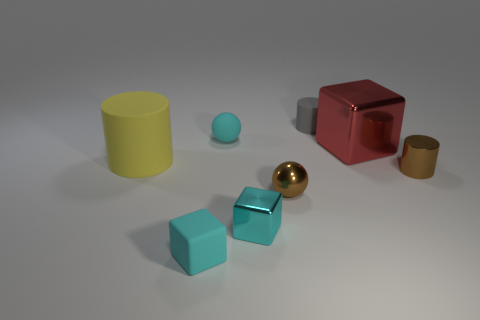There is a cylinder that is right of the big matte object and behind the brown cylinder; what is its size?
Your response must be concise. Small. There is a small cyan thing that is in front of the tiny cyan rubber sphere and right of the cyan rubber cube; what is its shape?
Provide a short and direct response. Cube. There is a small cube that is right of the cyan matte object that is in front of the yellow rubber cylinder; is there a yellow rubber cylinder that is to the right of it?
Your answer should be compact. No. What number of objects are rubber things that are in front of the gray matte thing or cubes that are in front of the large yellow cylinder?
Offer a terse response. 4. Are the small block right of the rubber block and the yellow thing made of the same material?
Provide a succinct answer. No. What is the material of the tiny thing that is both to the right of the tiny matte sphere and behind the red metal block?
Your response must be concise. Rubber. What is the color of the shiny thing that is in front of the tiny brown thing to the left of the tiny gray cylinder?
Ensure brevity in your answer.  Cyan. There is a gray thing that is the same shape as the large yellow matte thing; what is it made of?
Ensure brevity in your answer.  Rubber. There is a big object that is right of the small cyan object that is left of the small ball that is behind the large metal object; what is its color?
Keep it short and to the point. Red. What number of objects are red shiny blocks or metallic blocks?
Provide a succinct answer. 2. 